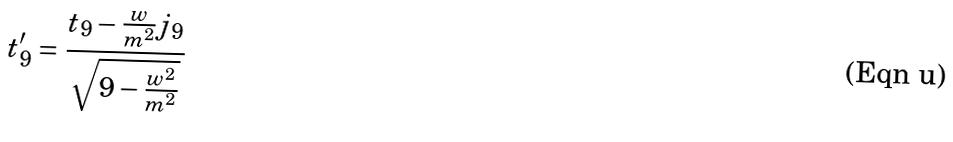<formula> <loc_0><loc_0><loc_500><loc_500>t _ { 9 } ^ { \prime } = \frac { t _ { 9 } - \frac { w } { m ^ { 2 } } j _ { 9 } } { \sqrt { 9 - \frac { w ^ { 2 } } { m ^ { 2 } } } }</formula> 